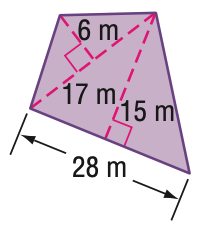Question: Find the area of the figure. Round to the nearest tenth if necessary.
Choices:
A. 261
B. 312
C. 471
D. 522
Answer with the letter. Answer: A 